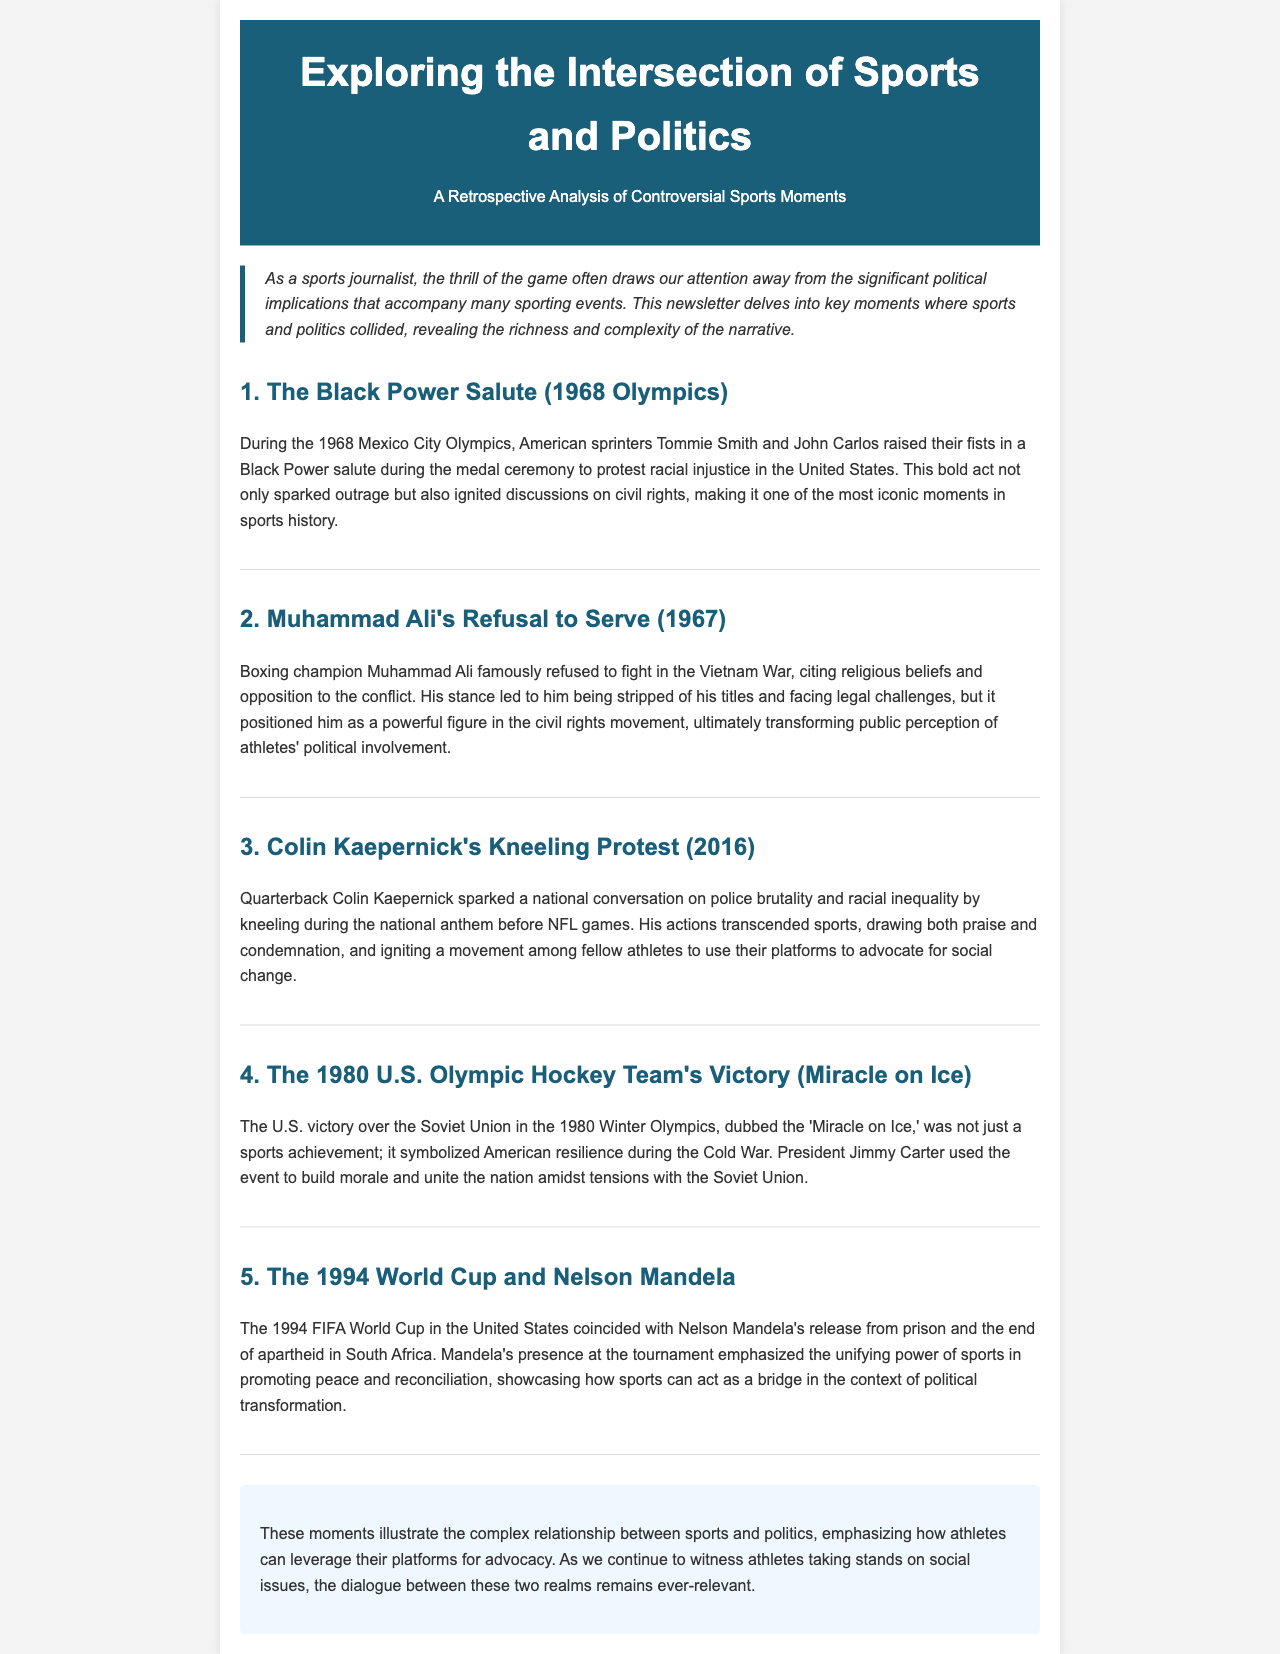What was the Black Power salute associated with? The Black Power salute was associated with a protest against racial injustice during the 1968 Olympics.
Answer: racial injustice In which year did Muhammad Ali refuse to serve in the Vietnam War? Muhammad Ali's refusal to serve in the Vietnam War occurred in 1967.
Answer: 1967 Who is the quarterback that initiated the kneeling protest in 2016? The quarterback who initiated the kneeling protest in 2016 is Colin Kaepernick.
Answer: Colin Kaepernick What event is referred to as the 'Miracle on Ice'? The 'Miracle on Ice' refers to the U.S. victory over the Soviet Union in the 1980 Winter Olympics.
Answer: U.S. victory over the Soviet Union What major global event coincided with the 1994 FIFA World Cup? The major global event that coincided with the 1994 FIFA World Cup was Nelson Mandela's release from prison and the end of apartheid.
Answer: Nelson Mandela's release What stance did athletes take after Colin Kaepernick's protest? After Colin Kaepernick's protest, many athletes began to use their platforms to advocate for social change.
Answer: advocate for social change How did President Jimmy Carter use the 1980 Olympic event? President Jimmy Carter used the 1980 Olympic event to build morale and unite the nation.
Answer: build morale and unite the nation What significant social movement did Muhammad Ali's actions transform? Muhammad Ali's actions transformed public perception of athletes' political involvement.
Answer: athletes' political involvement What does the newsletter emphasize about the role of athletes? The newsletter emphasizes that athletes can leverage their platforms for advocacy.
Answer: leverage their platforms for advocacy 